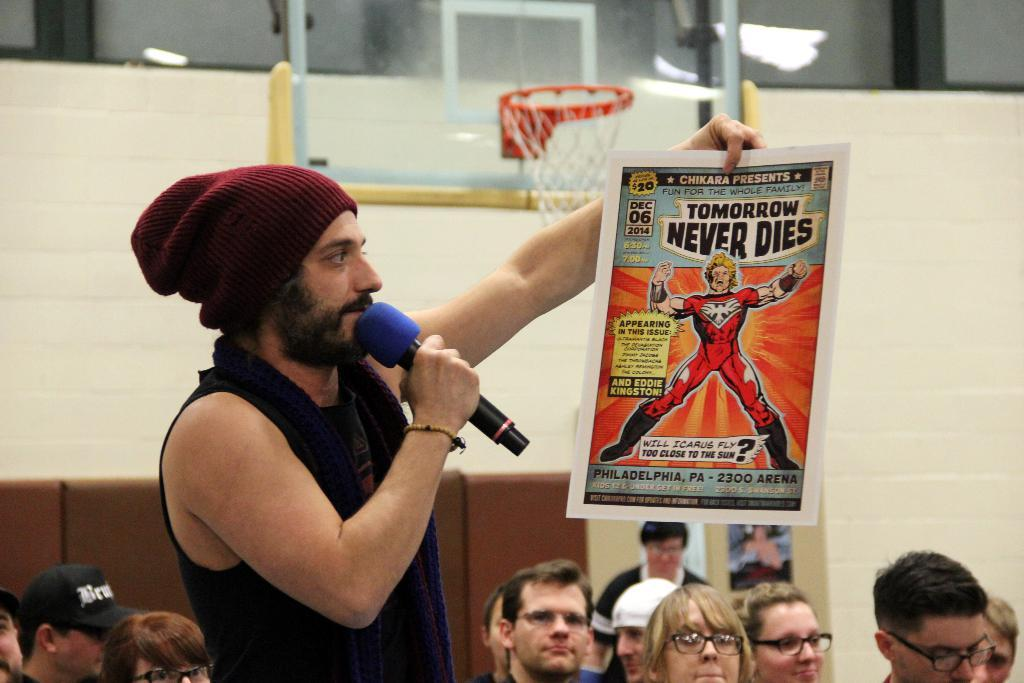How many people are in the image? There is a group of people in the image. What is one person in the group doing? One person is holding a mic. What else is the person holding the mic doing? The person holding the mic is also holding a paper. What is the price of the lumber in the image? There is no lumber present in the image, so it is not possible to determine its price. 